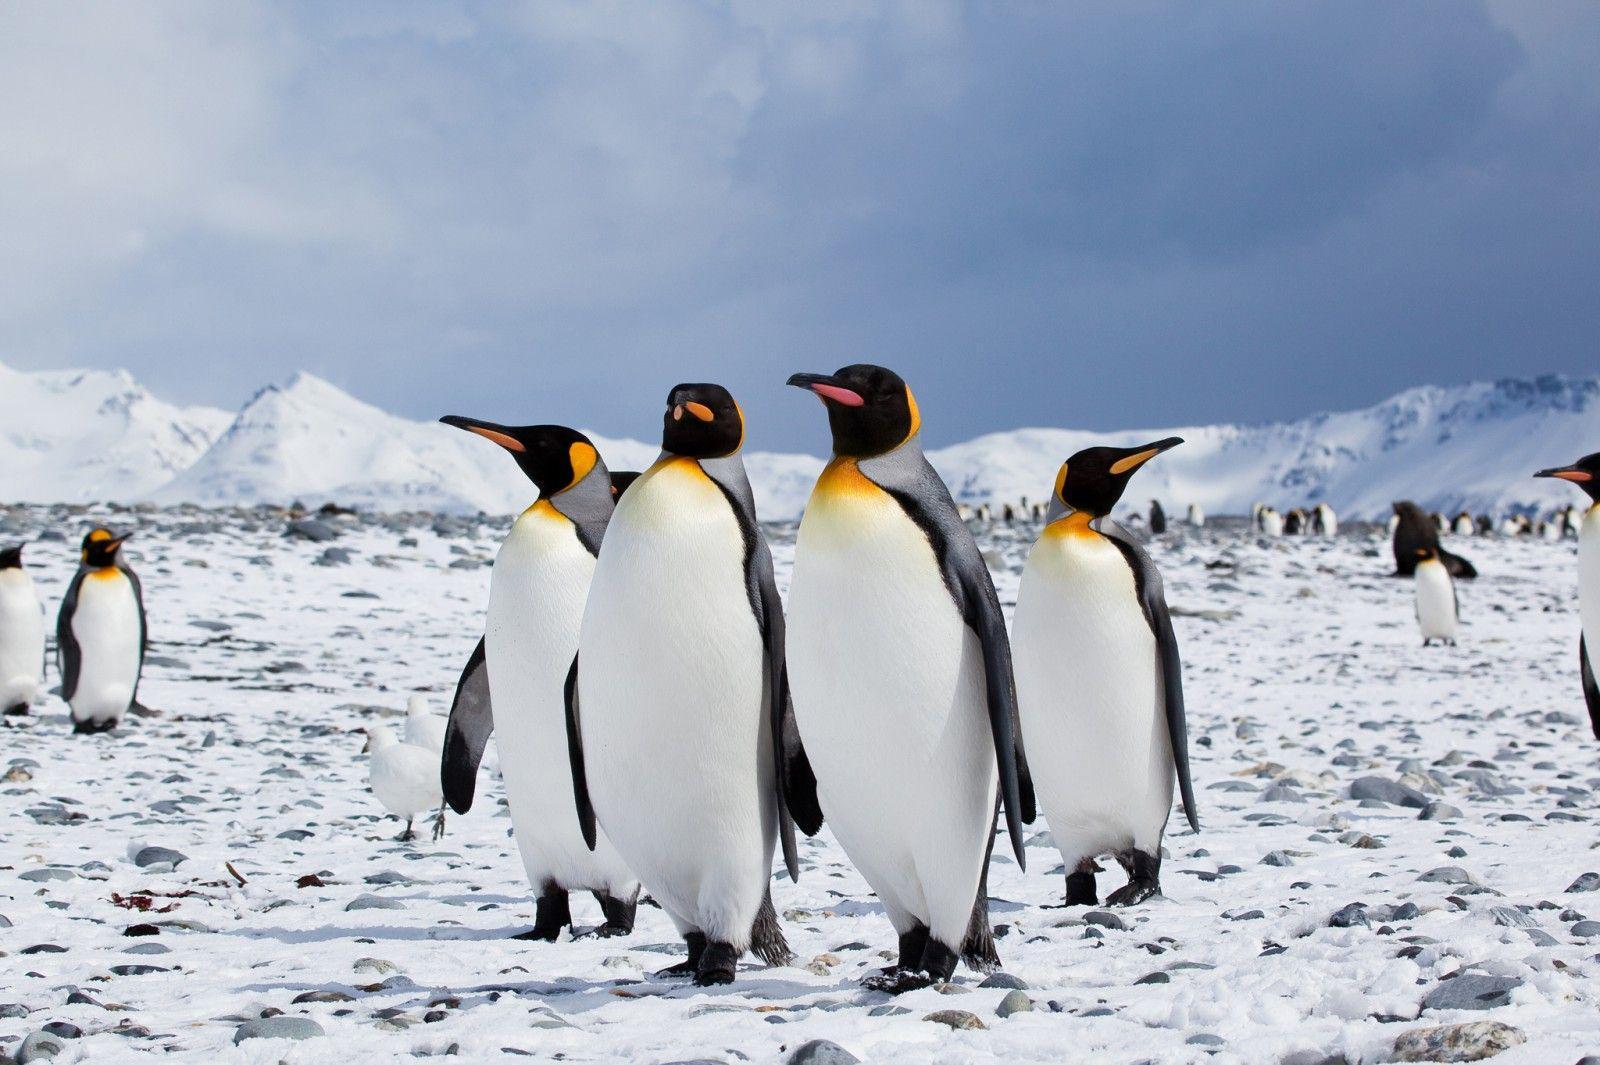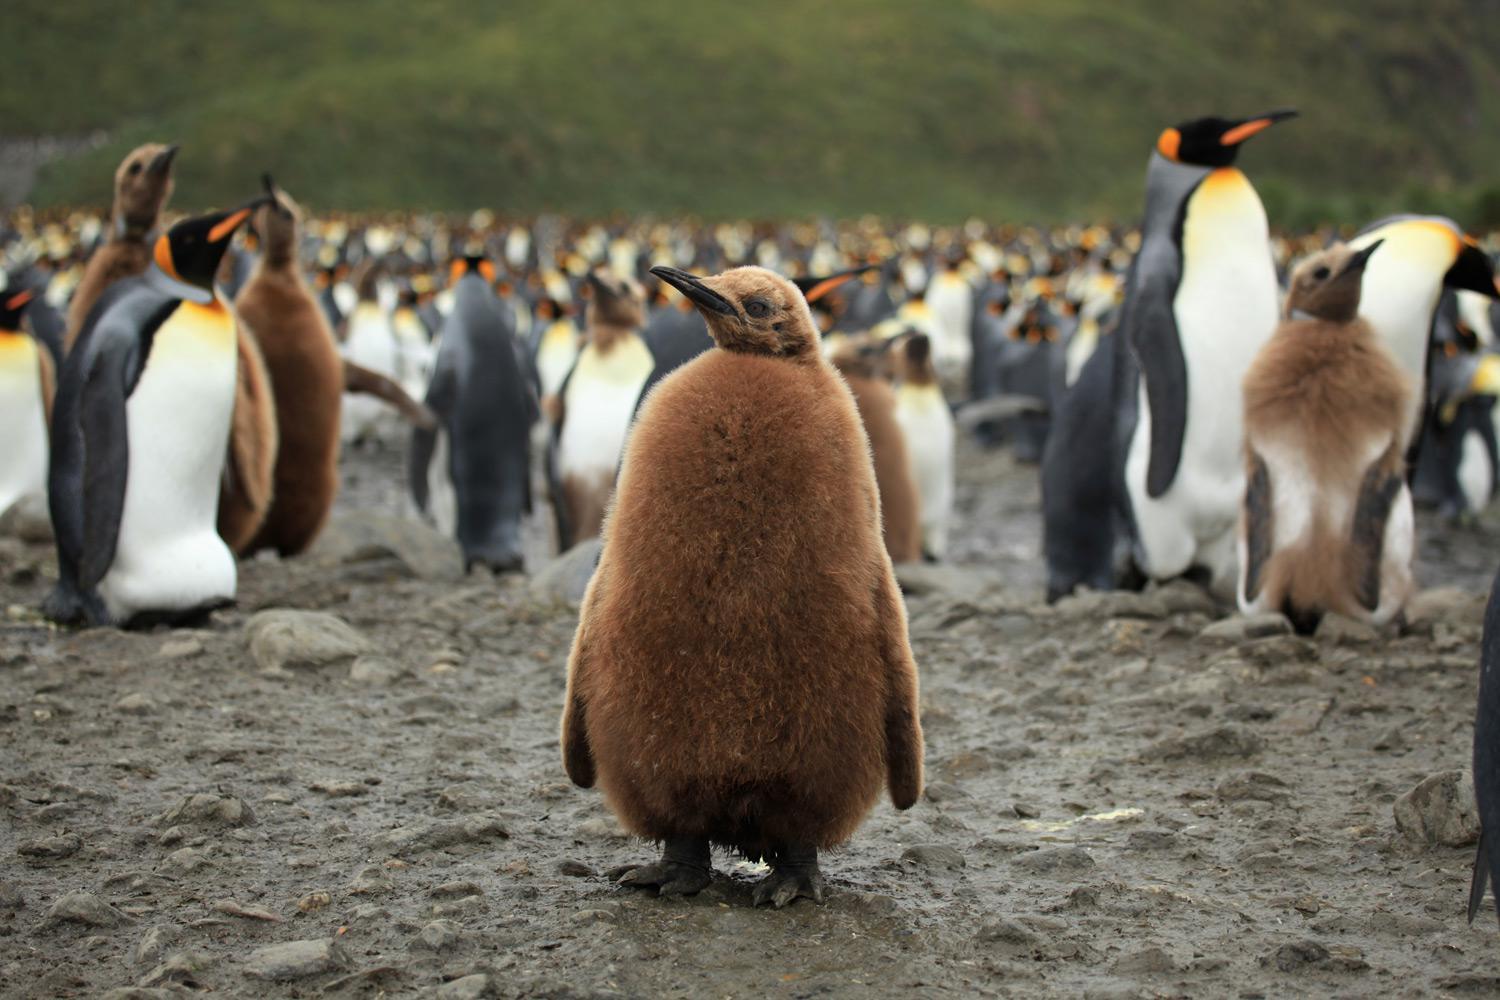The first image is the image on the left, the second image is the image on the right. For the images shown, is this caption "There are no more than five penguins" true? Answer yes or no. No. 